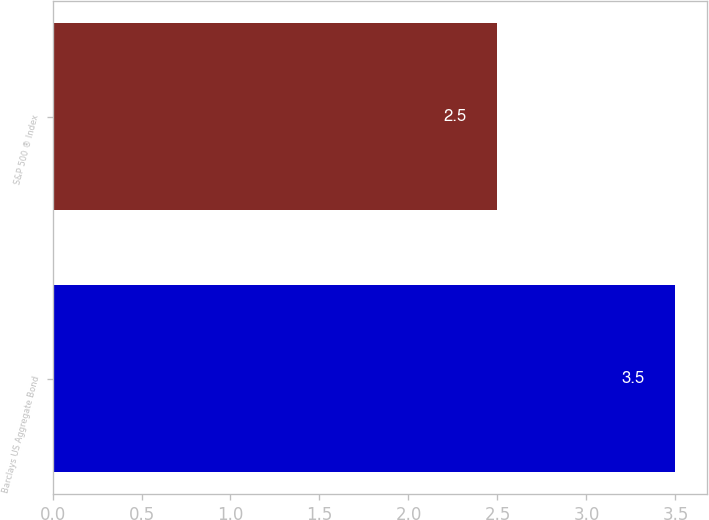Convert chart. <chart><loc_0><loc_0><loc_500><loc_500><bar_chart><fcel>Barclays US Aggregate Bond<fcel>S&P 500 ® Index<nl><fcel>3.5<fcel>2.5<nl></chart> 